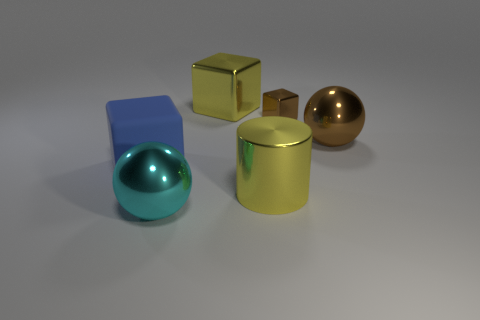Add 1 purple shiny cubes. How many objects exist? 7 Subtract all cylinders. How many objects are left? 5 Subtract all blue blocks. Subtract all large yellow cylinders. How many objects are left? 4 Add 6 large cylinders. How many large cylinders are left? 7 Add 6 brown things. How many brown things exist? 8 Subtract 0 cyan blocks. How many objects are left? 6 